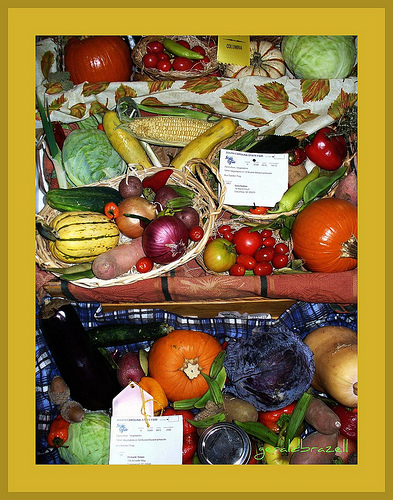<image>
Can you confirm if the pumpkin is next to the tomatoes? Yes. The pumpkin is positioned adjacent to the tomatoes, located nearby in the same general area. 